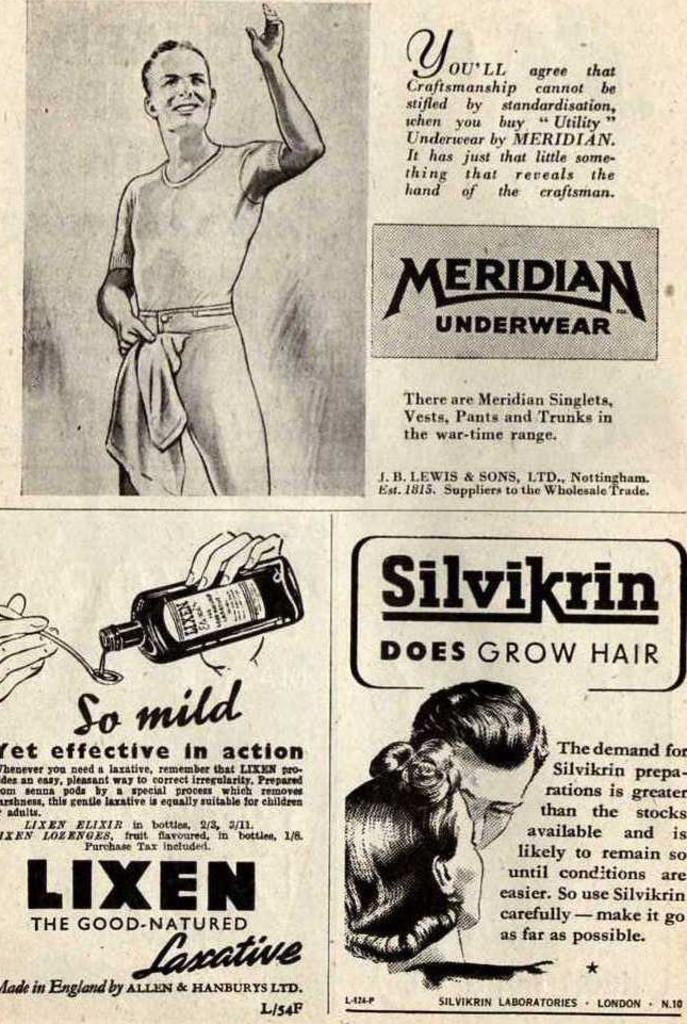What is the main subject of the paper in the image? The paper contains pictures of persons. Are there any other objects depicted on the paper besides the persons? Yes, the paper contains a picture of a bottle and a picture of a spoon. Is there any text present on the paper? Yes, there is text on the paper. How many snails can be seen crawling on the paper in the image? There are no snails present on the paper in the image. What type of ice is used to keep the paper cold in the image? There is no ice present in the image, and the paper is not cold. 